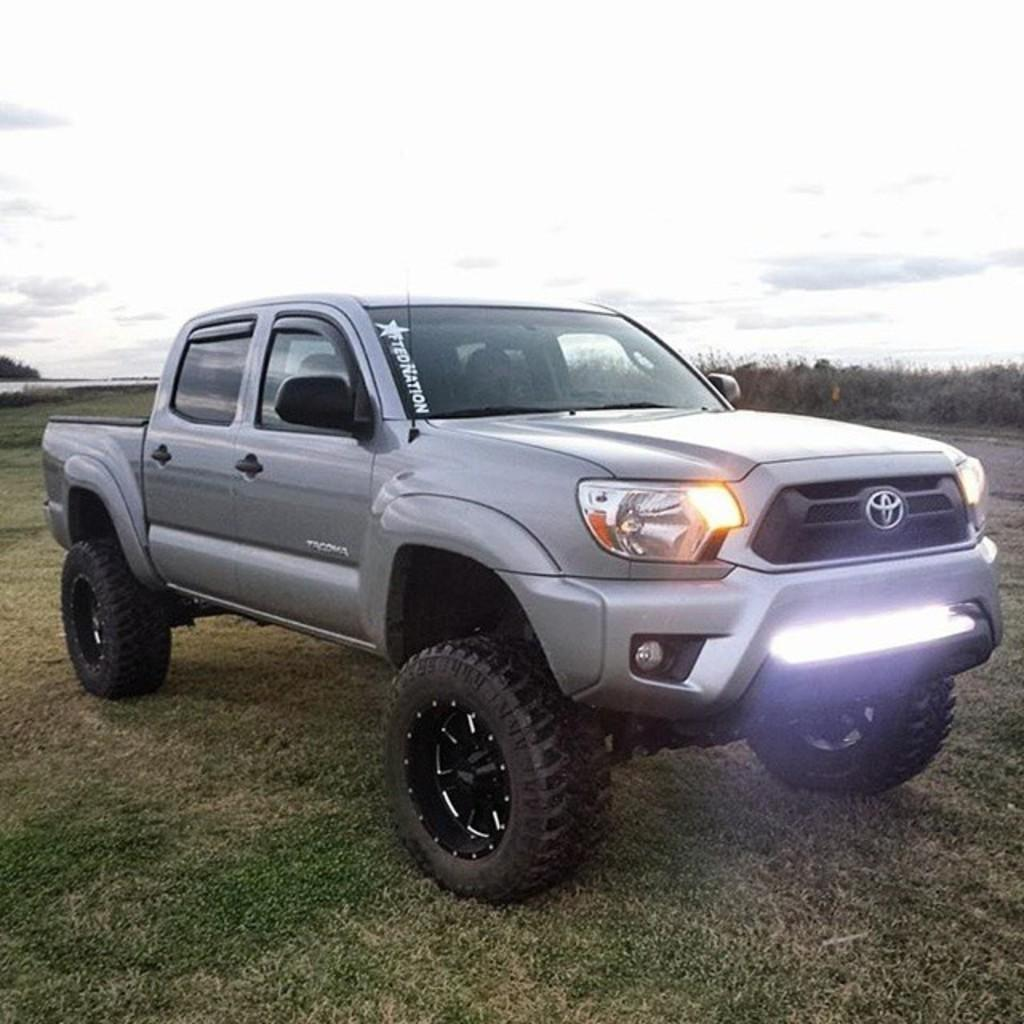What is the main subject of the image? There is a vehicle in the image. Can you describe the position of the vehicle? The vehicle is on the ground. What color is the vehicle? The vehicle is ash-colored. What can be seen in the background of the image? There are many trees and clouds in the background of the image. What part of the natural environment is visible in the image? The sky is visible in the background of the image. What type of holiday is being celebrated in the image? There is no indication of a holiday being celebrated in the image; it features a vehicle on the ground. How many bears can be seen interacting with the vehicle in the image? There are no bears present in the image; it only features a vehicle on the ground and the natural environment in the background. 